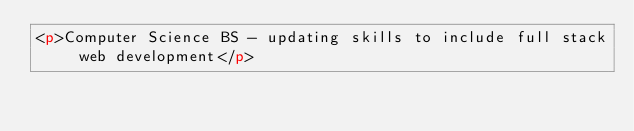<code> <loc_0><loc_0><loc_500><loc_500><_HTML_><p>Computer Science BS - updating skills to include full stack web development</p>
</code> 